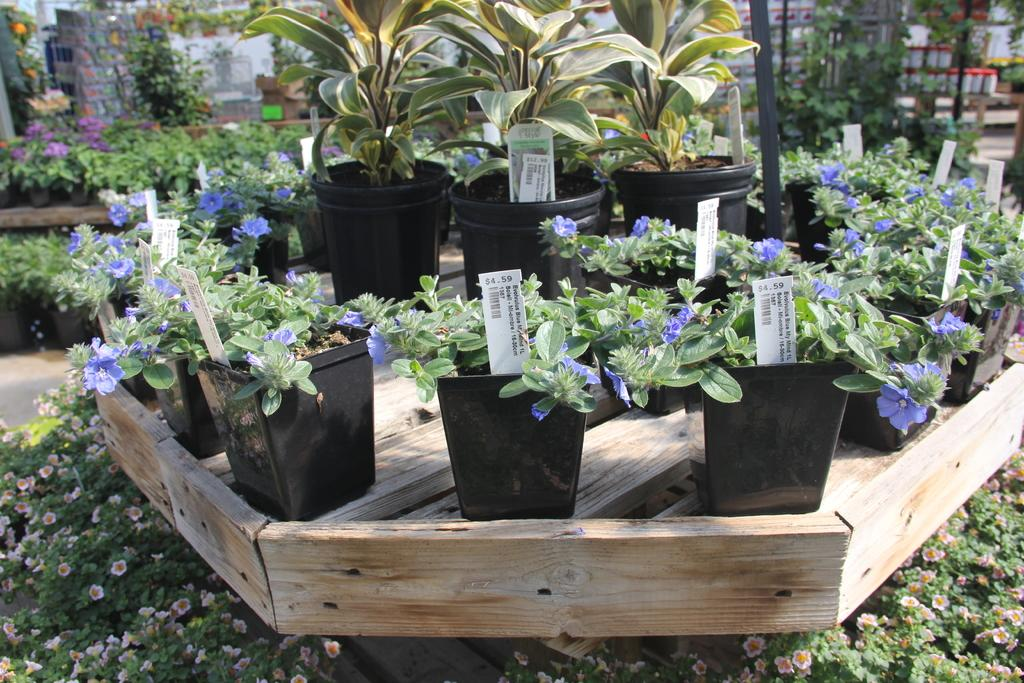What type of plants can be seen in the image? There are flower plants in the image. Where are the flower plants located? The flower plants are placed on a wooden table. How many spots on the table have flower plants? There are several spots on the table where the plants are placed. What can be seen in the background of the image? There are containers and poles in the background of the image. What type of bomb is being represented by the flower plants in the image? There is no bomb represented by the flower plants in the image; it is a display of flower plants on a wooden table. 